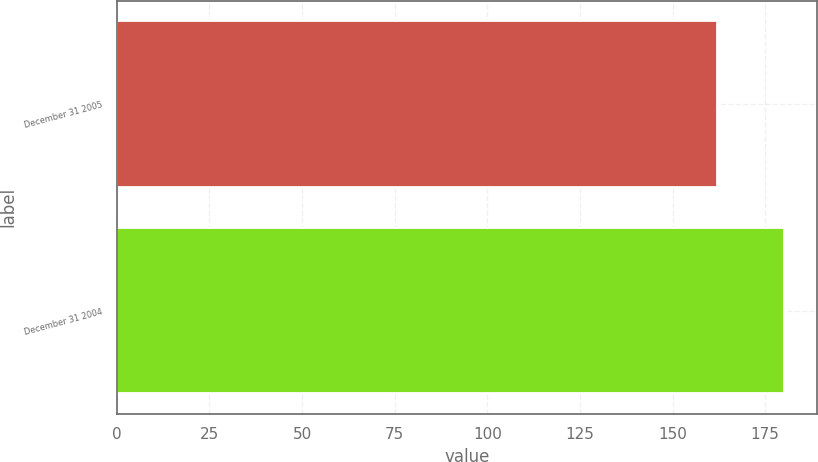<chart> <loc_0><loc_0><loc_500><loc_500><bar_chart><fcel>December 31 2005<fcel>December 31 2004<nl><fcel>162<fcel>180<nl></chart> 